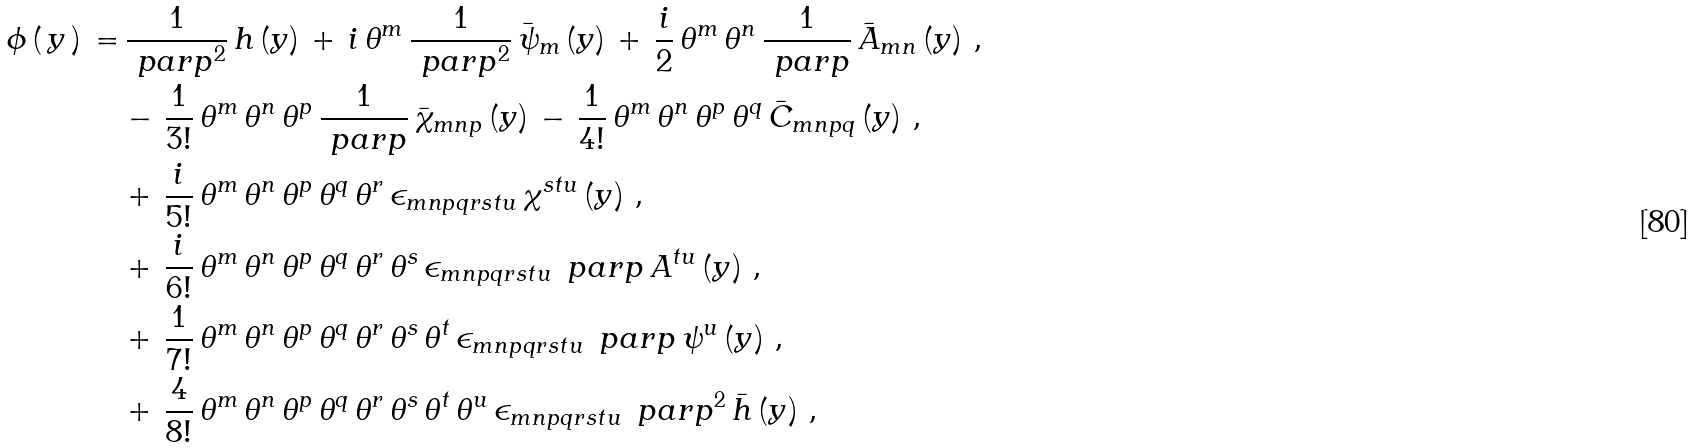<formula> <loc_0><loc_0><loc_500><loc_500>\phi \, ( \, y \, ) \, = & \, \frac { 1 } { { \ p a r p } ^ { 2 } } \, h \, ( y ) \, + \, i \, \theta ^ { m } \, \frac { 1 } { { \ p a r p } ^ { 2 } } \, { \bar { \psi } } _ { m } \, ( y ) \, + \, \frac { i } { 2 } \, \theta ^ { m } \, \theta ^ { n } \, \frac { 1 } { \ p a r p } \, { \bar { A } } _ { m n } \, ( y ) \ , \\ \, & - \, \frac { 1 } { 3 ! } \, \theta ^ { m } \, \theta ^ { n } \, \theta ^ { p } \, \frac { 1 } { \ p a r p } \, { \bar { \chi } } _ { m n p } \, ( y ) \, - \, \frac { 1 } { 4 ! } \, \theta ^ { m } \, \theta ^ { n } \, \theta ^ { p } \, \theta ^ { q } \, { \bar { C } } _ { m n p q } \, ( y ) \ , \\ \, & + \, \frac { i } { 5 ! } \, \theta ^ { m } \, \theta ^ { n } \, \theta ^ { p } \, \theta ^ { q } \, \theta ^ { r } \, \epsilon _ { m n p q r s t u } \, \chi ^ { s t u } \, ( y ) \ , \\ \, & + \, \frac { i } { 6 ! } \, \theta ^ { m } \, \theta ^ { n } \, \theta ^ { p } \, \theta ^ { q } \, \theta ^ { r } \, \theta ^ { s } \, \epsilon _ { m n p q r s t u } \, \ p a r p \, A ^ { t u } \, ( y ) \ , \\ \, & + \, \frac { 1 } { 7 ! } \, \theta ^ { m } \, \theta ^ { n } \, \theta ^ { p } \, \theta ^ { q } \, \theta ^ { r } \, \theta ^ { s } \, \theta ^ { t } \, \epsilon _ { m n p q r s t u } \, \ p a r p \, \psi ^ { u } \, ( y ) \ , \\ \, & + \, \frac { 4 } { 8 ! } \, \theta ^ { m } \, \theta ^ { n } \, \theta ^ { p } \, \theta ^ { q } \, \theta ^ { r } \, \theta ^ { s } \, \theta ^ { t } \, \theta ^ { u } \, \epsilon _ { m n p q r s t u } \, { \ p a r p } ^ { 2 } \, { \bar { h } } \, ( y ) \ ,</formula> 